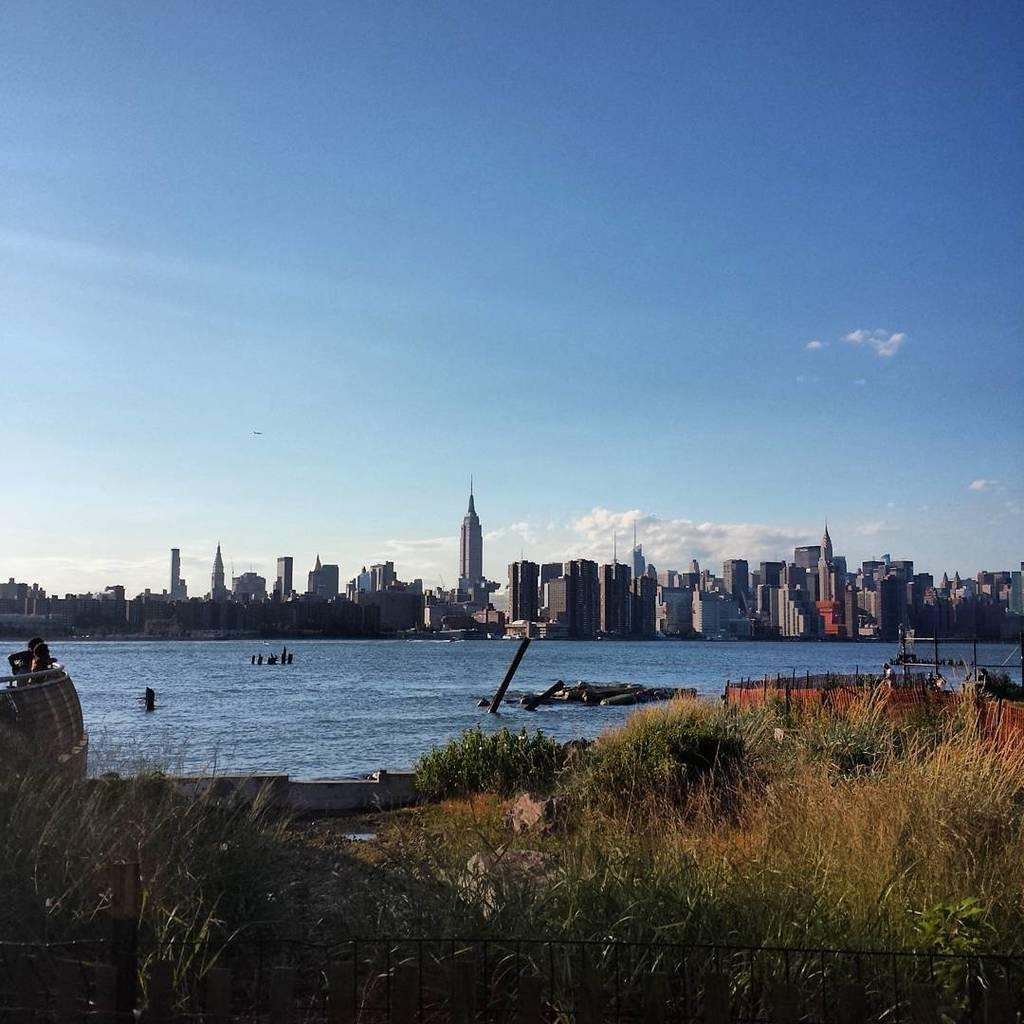What type of vegetation is present in the front of the image? There is grass in the front of the image. What can be seen in the middle of the image? There is water in the middle of the image. What type of structures are visible in the background of the image? There are buildings in the background of the image. What is visible at the top of the image? The sky is visible at the top of the image. How does the grass adjust its height in the image? The grass does not adjust its height in the image; it is a static image. What type of brake system is used by the water in the image? There is no brake system present in the image, as it is a natural body of water. 